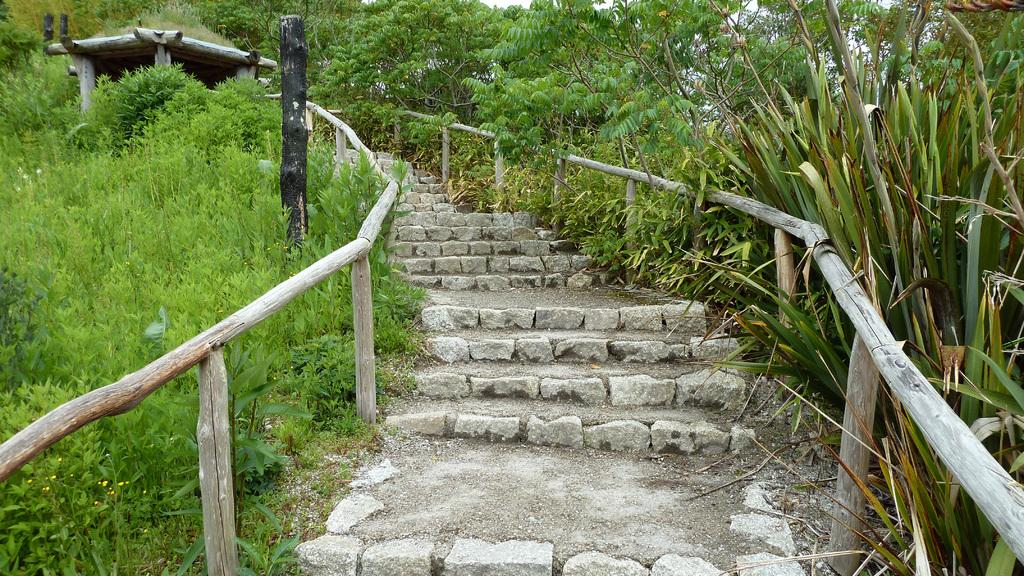What type of structure is present in the image? There are stairs in the image. What is located near the stairs? There is a fence near the stairs. What type of vegetation can be seen in the image? There are trees in the image. What can be seen in the background of the image? There is a hut and the sky visible in the background of the image. How many horses are visible in the image? There are no horses present in the image. What type of chair is located in space in the image? There is no chair or space present in the image. 